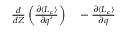<formula> <loc_0><loc_0><loc_500><loc_500>\begin{array} { r l } { \frac { d } { d Z } \left ( \frac { \partial \langle L _ { c } \rangle } { \partial q ^ { \prime } } \right ) } & - \frac { \partial \langle L _ { c } \rangle } { \partial q } } \end{array}</formula> 